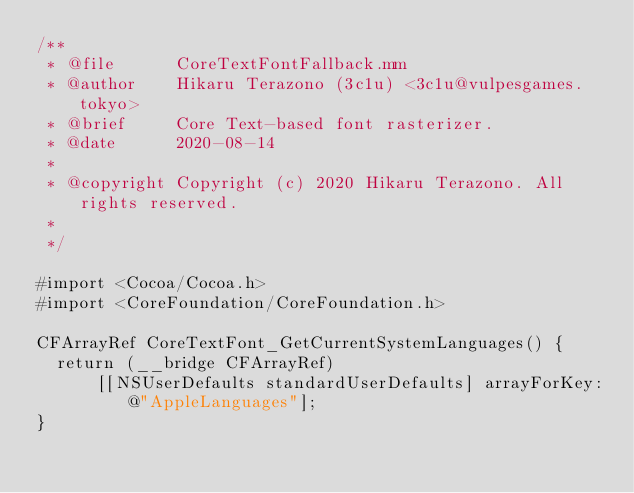<code> <loc_0><loc_0><loc_500><loc_500><_ObjectiveC_>/**
 * @file      CoreTextFontFallback.mm
 * @author    Hikaru Terazono (3c1u) <3c1u@vulpesgames.tokyo>
 * @brief     Core Text-based font rasterizer.
 * @date      2020-08-14
 *
 * @copyright Copyright (c) 2020 Hikaru Terazono. All rights reserved.
 *
 */

#import <Cocoa/Cocoa.h>
#import <CoreFoundation/CoreFoundation.h>

CFArrayRef CoreTextFont_GetCurrentSystemLanguages() {
  return (__bridge CFArrayRef)
      [[NSUserDefaults standardUserDefaults] arrayForKey:@"AppleLanguages"];
}
</code> 